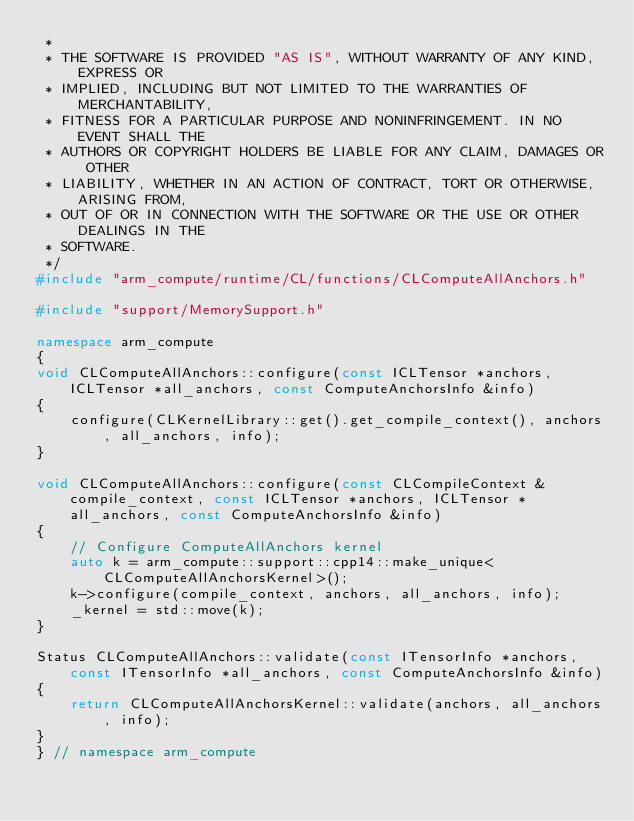<code> <loc_0><loc_0><loc_500><loc_500><_C++_> *
 * THE SOFTWARE IS PROVIDED "AS IS", WITHOUT WARRANTY OF ANY KIND, EXPRESS OR
 * IMPLIED, INCLUDING BUT NOT LIMITED TO THE WARRANTIES OF MERCHANTABILITY,
 * FITNESS FOR A PARTICULAR PURPOSE AND NONINFRINGEMENT. IN NO EVENT SHALL THE
 * AUTHORS OR COPYRIGHT HOLDERS BE LIABLE FOR ANY CLAIM, DAMAGES OR OTHER
 * LIABILITY, WHETHER IN AN ACTION OF CONTRACT, TORT OR OTHERWISE, ARISING FROM,
 * OUT OF OR IN CONNECTION WITH THE SOFTWARE OR THE USE OR OTHER DEALINGS IN THE
 * SOFTWARE.
 */
#include "arm_compute/runtime/CL/functions/CLComputeAllAnchors.h"

#include "support/MemorySupport.h"

namespace arm_compute
{
void CLComputeAllAnchors::configure(const ICLTensor *anchors, ICLTensor *all_anchors, const ComputeAnchorsInfo &info)
{
    configure(CLKernelLibrary::get().get_compile_context(), anchors, all_anchors, info);
}

void CLComputeAllAnchors::configure(const CLCompileContext &compile_context, const ICLTensor *anchors, ICLTensor *all_anchors, const ComputeAnchorsInfo &info)
{
    // Configure ComputeAllAnchors kernel
    auto k = arm_compute::support::cpp14::make_unique<CLComputeAllAnchorsKernel>();
    k->configure(compile_context, anchors, all_anchors, info);
    _kernel = std::move(k);
}

Status CLComputeAllAnchors::validate(const ITensorInfo *anchors, const ITensorInfo *all_anchors, const ComputeAnchorsInfo &info)
{
    return CLComputeAllAnchorsKernel::validate(anchors, all_anchors, info);
}
} // namespace arm_compute
</code> 